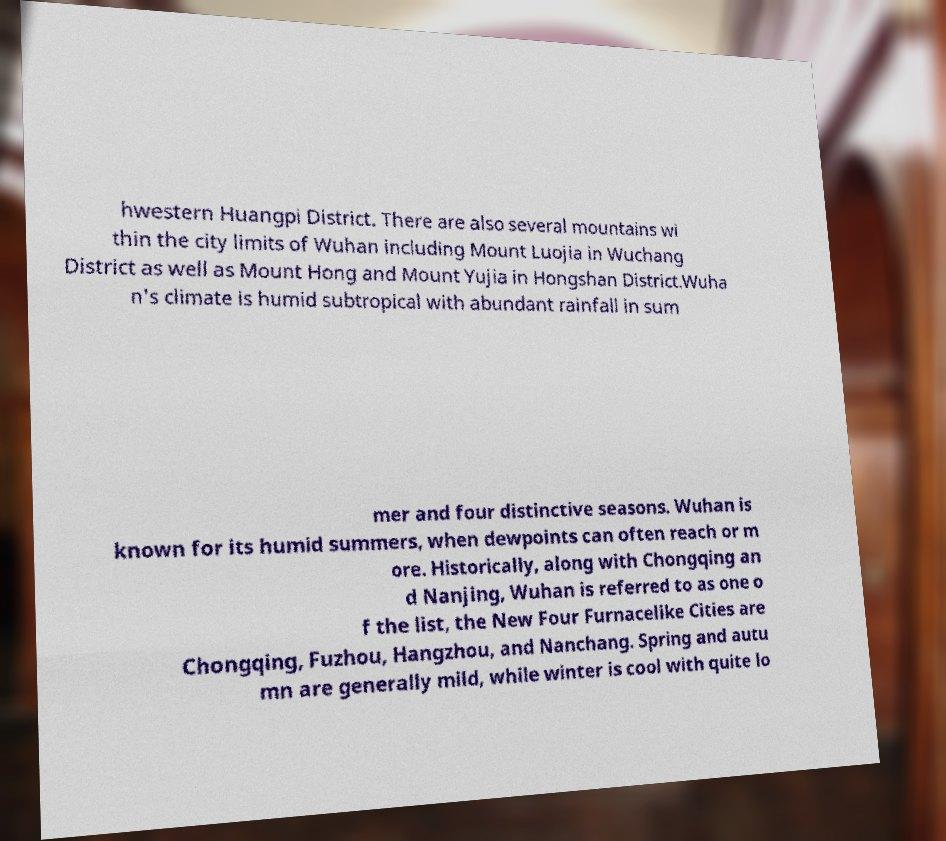I need the written content from this picture converted into text. Can you do that? hwestern Huangpi District. There are also several mountains wi thin the city limits of Wuhan including Mount Luojia in Wuchang District as well as Mount Hong and Mount Yujia in Hongshan District.Wuha n's climate is humid subtropical with abundant rainfall in sum mer and four distinctive seasons. Wuhan is known for its humid summers, when dewpoints can often reach or m ore. Historically, along with Chongqing an d Nanjing, Wuhan is referred to as one o f the list, the New Four Furnacelike Cities are Chongqing, Fuzhou, Hangzhou, and Nanchang. Spring and autu mn are generally mild, while winter is cool with quite lo 